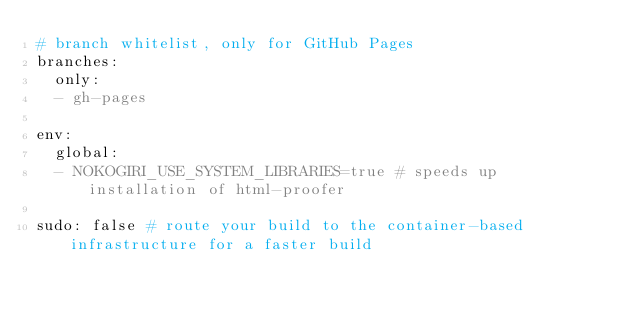<code> <loc_0><loc_0><loc_500><loc_500><_YAML_># branch whitelist, only for GitHub Pages
branches:
  only:
  - gh-pages

env:
  global:
  - NOKOGIRI_USE_SYSTEM_LIBRARIES=true # speeds up installation of html-proofer

sudo: false # route your build to the container-based infrastructure for a faster build</code> 